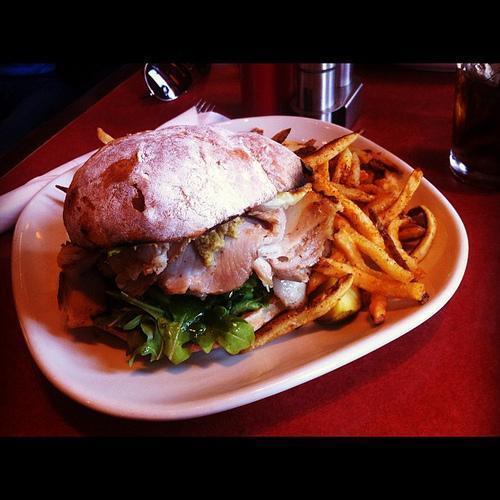How many sandwiches?
Give a very brief answer. 1. 